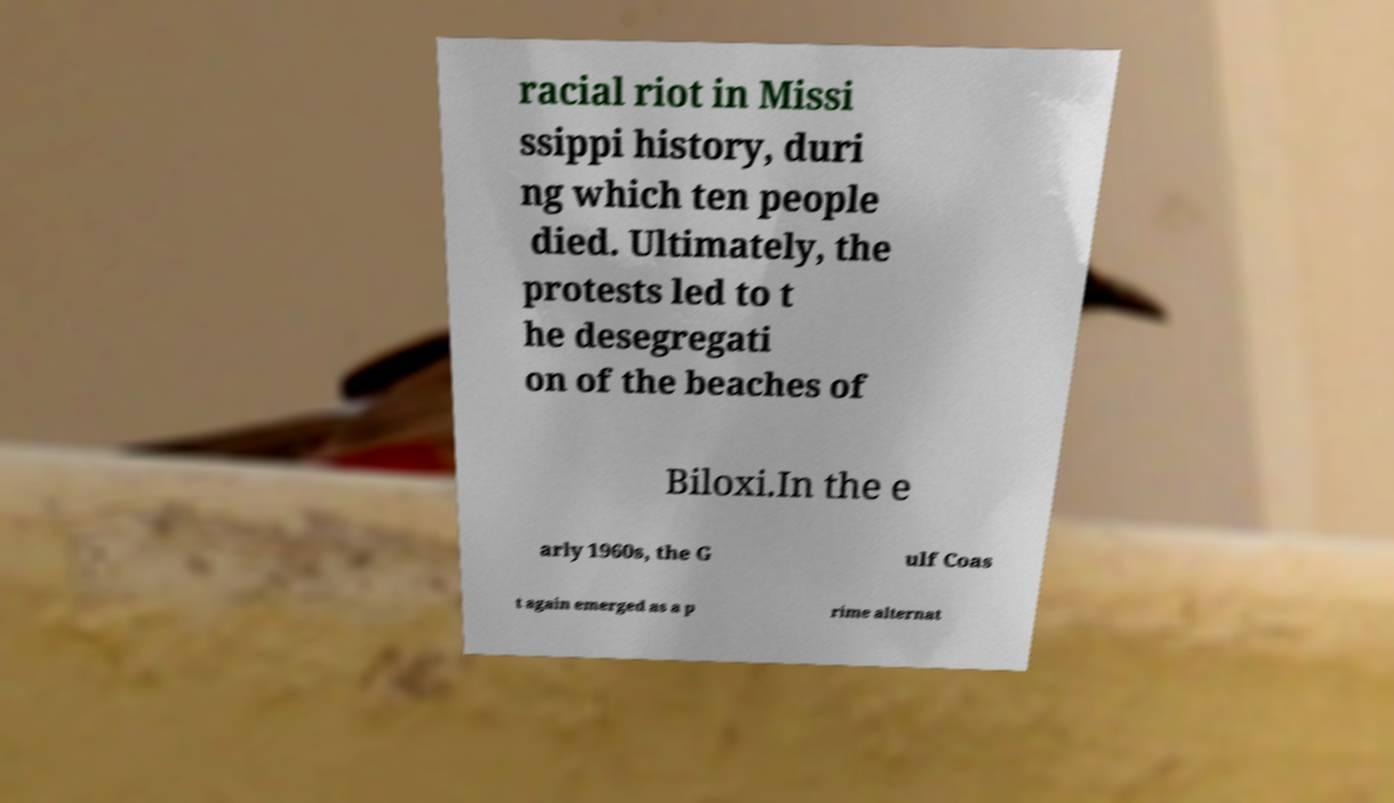Please read and relay the text visible in this image. What does it say? racial riot in Missi ssippi history, duri ng which ten people died. Ultimately, the protests led to t he desegregati on of the beaches of Biloxi.In the e arly 1960s, the G ulf Coas t again emerged as a p rime alternat 